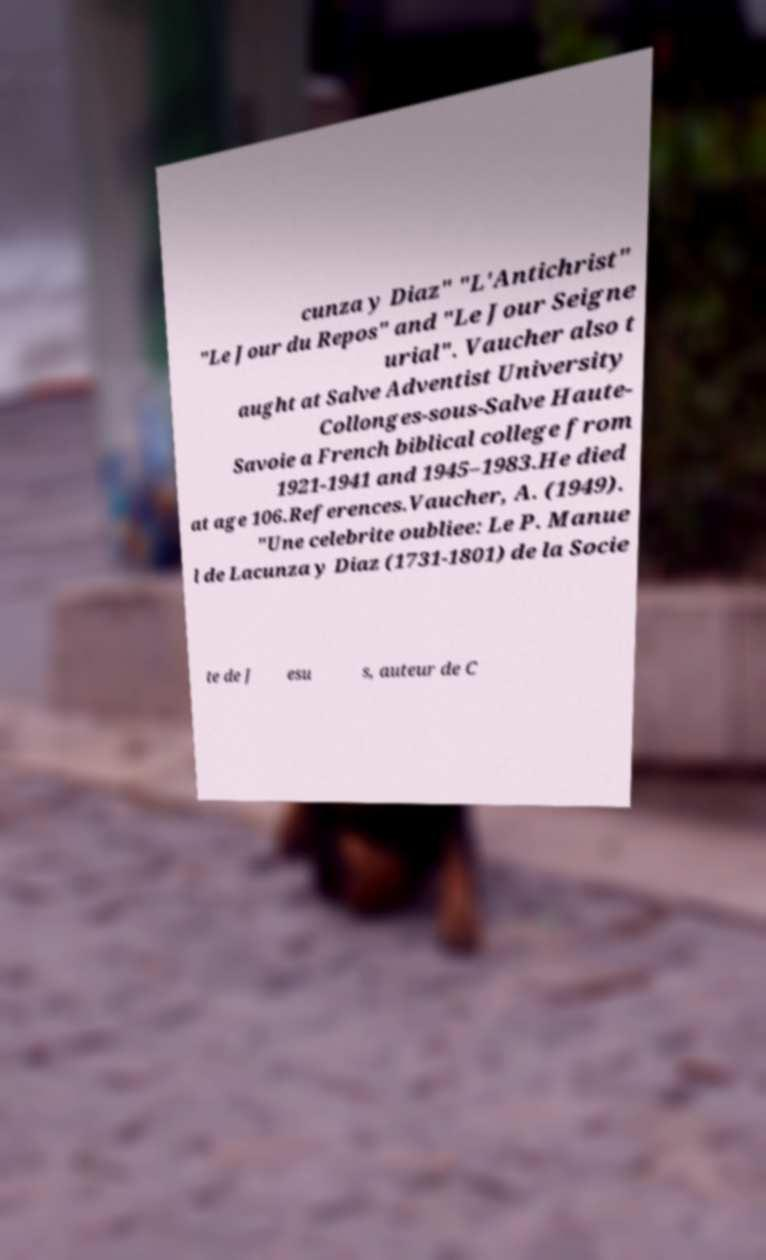Please identify and transcribe the text found in this image. cunza y Diaz" "L'Antichrist" "Le Jour du Repos" and "Le Jour Seigne urial". Vaucher also t aught at Salve Adventist University Collonges-sous-Salve Haute- Savoie a French biblical college from 1921-1941 and 1945–1983.He died at age 106.References.Vaucher, A. (1949). "Une celebrite oubliee: Le P. Manue l de Lacunza y Diaz (1731-1801) de la Socie te de J esu s, auteur de C 